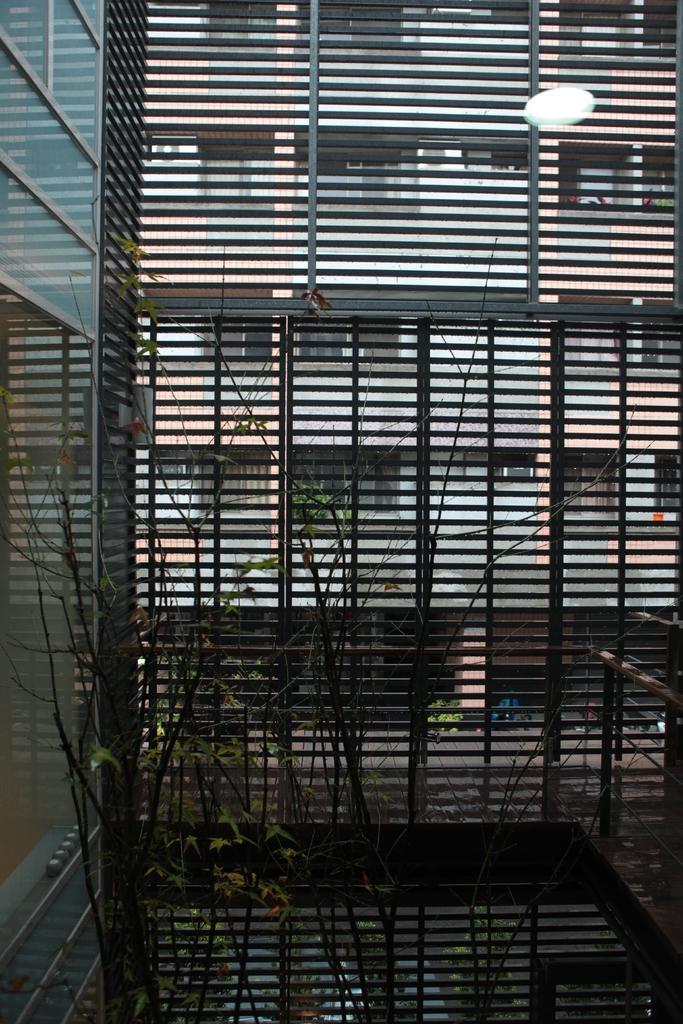Describe this image in one or two sentences. In this picture I can see the plants in front and I can see the iron bars and through the bars I can see a building. 